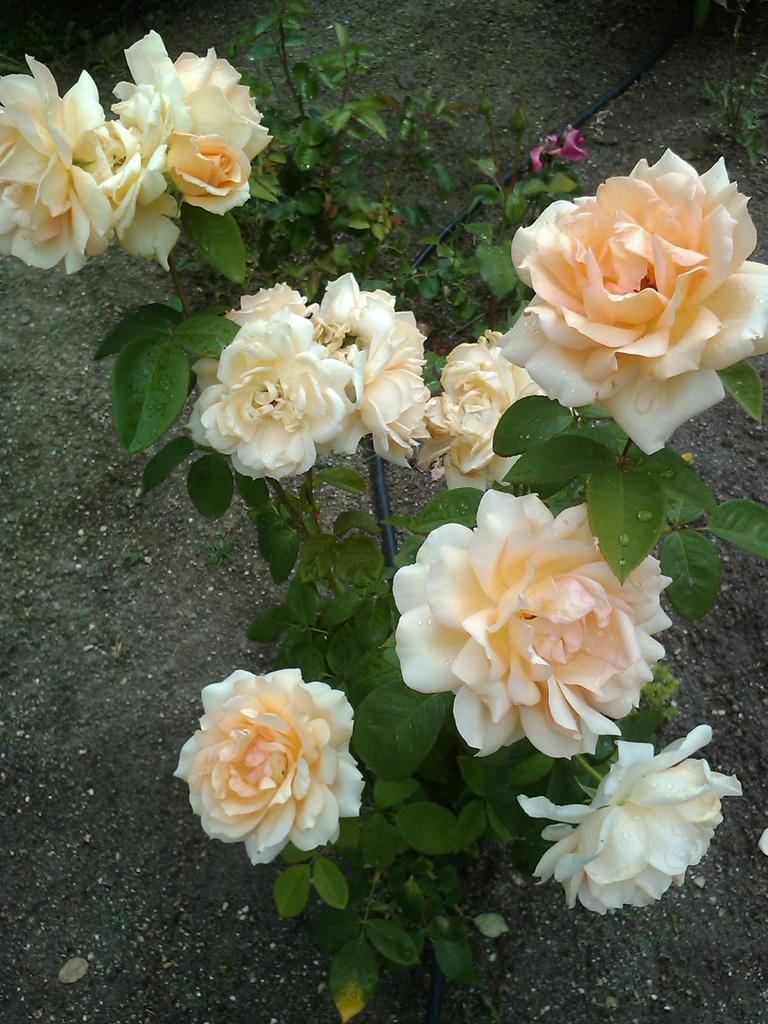Please provide a concise description of this image. In the foreground of this image, there are rose flowers to the plant. In the background, there is ground and a black pipe. 